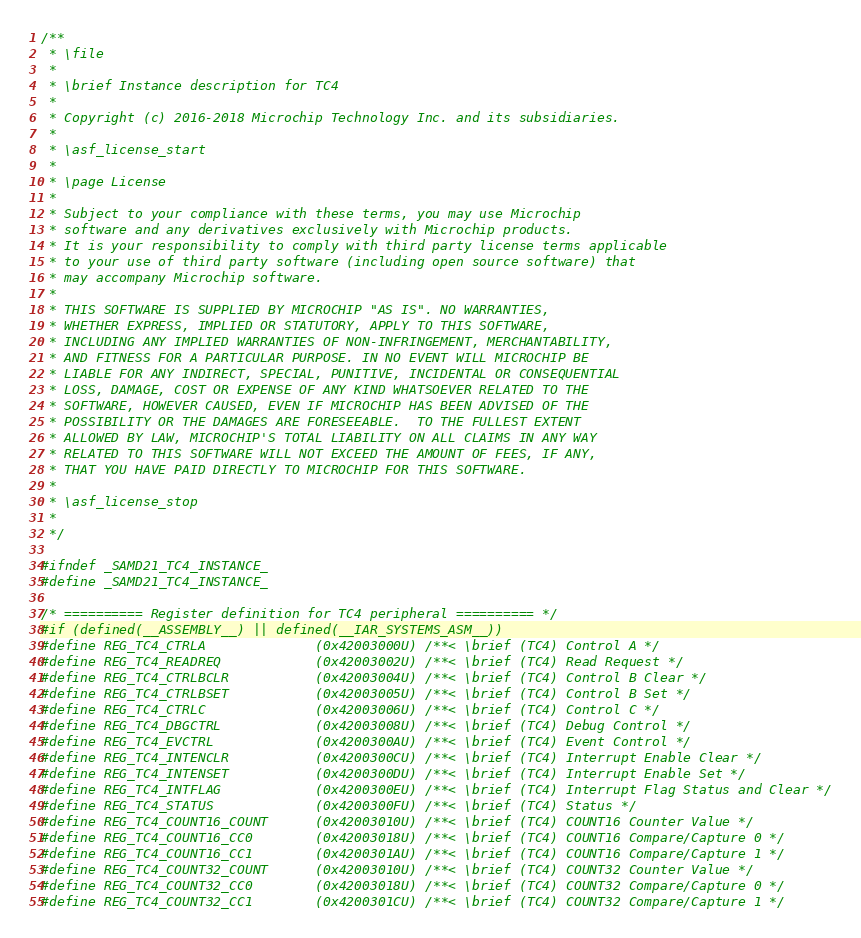Convert code to text. <code><loc_0><loc_0><loc_500><loc_500><_C_>/**
 * \file
 *
 * \brief Instance description for TC4
 *
 * Copyright (c) 2016-2018 Microchip Technology Inc. and its subsidiaries.
 *
 * \asf_license_start
 *
 * \page License
 *
 * Subject to your compliance with these terms, you may use Microchip
 * software and any derivatives exclusively with Microchip products.
 * It is your responsibility to comply with third party license terms applicable
 * to your use of third party software (including open source software) that
 * may accompany Microchip software.
 *
 * THIS SOFTWARE IS SUPPLIED BY MICROCHIP "AS IS". NO WARRANTIES,
 * WHETHER EXPRESS, IMPLIED OR STATUTORY, APPLY TO THIS SOFTWARE,
 * INCLUDING ANY IMPLIED WARRANTIES OF NON-INFRINGEMENT, MERCHANTABILITY,
 * AND FITNESS FOR A PARTICULAR PURPOSE. IN NO EVENT WILL MICROCHIP BE
 * LIABLE FOR ANY INDIRECT, SPECIAL, PUNITIVE, INCIDENTAL OR CONSEQUENTIAL
 * LOSS, DAMAGE, COST OR EXPENSE OF ANY KIND WHATSOEVER RELATED TO THE
 * SOFTWARE, HOWEVER CAUSED, EVEN IF MICROCHIP HAS BEEN ADVISED OF THE
 * POSSIBILITY OR THE DAMAGES ARE FORESEEABLE.  TO THE FULLEST EXTENT
 * ALLOWED BY LAW, MICROCHIP'S TOTAL LIABILITY ON ALL CLAIMS IN ANY WAY
 * RELATED TO THIS SOFTWARE WILL NOT EXCEED THE AMOUNT OF FEES, IF ANY,
 * THAT YOU HAVE PAID DIRECTLY TO MICROCHIP FOR THIS SOFTWARE.
 *
 * \asf_license_stop
 *
 */

#ifndef _SAMD21_TC4_INSTANCE_
#define _SAMD21_TC4_INSTANCE_

/* ========== Register definition for TC4 peripheral ========== */
#if (defined(__ASSEMBLY__) || defined(__IAR_SYSTEMS_ASM__))
#define REG_TC4_CTRLA              (0x42003000U) /**< \brief (TC4) Control A */
#define REG_TC4_READREQ            (0x42003002U) /**< \brief (TC4) Read Request */
#define REG_TC4_CTRLBCLR           (0x42003004U) /**< \brief (TC4) Control B Clear */
#define REG_TC4_CTRLBSET           (0x42003005U) /**< \brief (TC4) Control B Set */
#define REG_TC4_CTRLC              (0x42003006U) /**< \brief (TC4) Control C */
#define REG_TC4_DBGCTRL            (0x42003008U) /**< \brief (TC4) Debug Control */
#define REG_TC4_EVCTRL             (0x4200300AU) /**< \brief (TC4) Event Control */
#define REG_TC4_INTENCLR           (0x4200300CU) /**< \brief (TC4) Interrupt Enable Clear */
#define REG_TC4_INTENSET           (0x4200300DU) /**< \brief (TC4) Interrupt Enable Set */
#define REG_TC4_INTFLAG            (0x4200300EU) /**< \brief (TC4) Interrupt Flag Status and Clear */
#define REG_TC4_STATUS             (0x4200300FU) /**< \brief (TC4) Status */
#define REG_TC4_COUNT16_COUNT      (0x42003010U) /**< \brief (TC4) COUNT16 Counter Value */
#define REG_TC4_COUNT16_CC0        (0x42003018U) /**< \brief (TC4) COUNT16 Compare/Capture 0 */
#define REG_TC4_COUNT16_CC1        (0x4200301AU) /**< \brief (TC4) COUNT16 Compare/Capture 1 */
#define REG_TC4_COUNT32_COUNT      (0x42003010U) /**< \brief (TC4) COUNT32 Counter Value */
#define REG_TC4_COUNT32_CC0        (0x42003018U) /**< \brief (TC4) COUNT32 Compare/Capture 0 */
#define REG_TC4_COUNT32_CC1        (0x4200301CU) /**< \brief (TC4) COUNT32 Compare/Capture 1 */</code> 